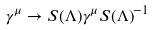<formula> <loc_0><loc_0><loc_500><loc_500>\gamma ^ { \mu } \to S ( \Lambda ) \gamma ^ { \mu } { S ( \Lambda ) } ^ { - 1 }</formula> 